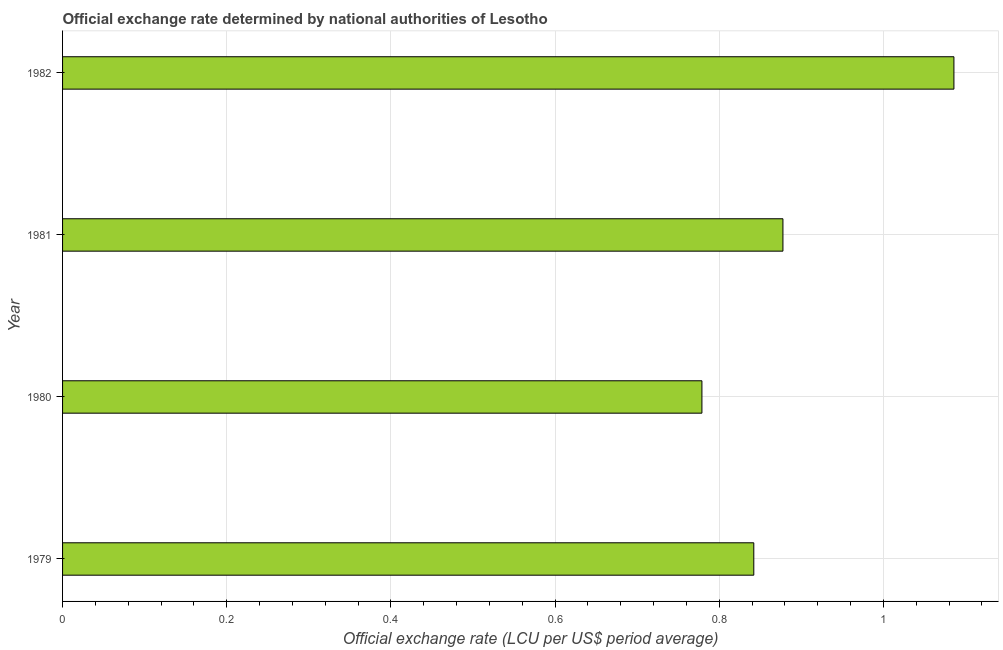What is the title of the graph?
Offer a terse response. Official exchange rate determined by national authorities of Lesotho. What is the label or title of the X-axis?
Offer a terse response. Official exchange rate (LCU per US$ period average). What is the label or title of the Y-axis?
Give a very brief answer. Year. What is the official exchange rate in 1980?
Offer a very short reply. 0.78. Across all years, what is the maximum official exchange rate?
Give a very brief answer. 1.09. Across all years, what is the minimum official exchange rate?
Offer a terse response. 0.78. In which year was the official exchange rate maximum?
Make the answer very short. 1982. What is the sum of the official exchange rate?
Provide a succinct answer. 3.58. What is the difference between the official exchange rate in 1979 and 1981?
Make the answer very short. -0.04. What is the average official exchange rate per year?
Provide a succinct answer. 0.9. What is the median official exchange rate?
Make the answer very short. 0.86. In how many years, is the official exchange rate greater than 1.04 ?
Offer a very short reply. 1. Do a majority of the years between 1982 and 1980 (inclusive) have official exchange rate greater than 0.28 ?
Provide a succinct answer. Yes. What is the ratio of the official exchange rate in 1981 to that in 1982?
Ensure brevity in your answer.  0.81. Is the official exchange rate in 1979 less than that in 1981?
Offer a very short reply. Yes. What is the difference between the highest and the second highest official exchange rate?
Your answer should be compact. 0.21. What is the difference between the highest and the lowest official exchange rate?
Offer a very short reply. 0.31. Are all the bars in the graph horizontal?
Provide a succinct answer. Yes. What is the difference between two consecutive major ticks on the X-axis?
Offer a very short reply. 0.2. Are the values on the major ticks of X-axis written in scientific E-notation?
Offer a terse response. No. What is the Official exchange rate (LCU per US$ period average) of 1979?
Your answer should be compact. 0.84. What is the Official exchange rate (LCU per US$ period average) in 1980?
Give a very brief answer. 0.78. What is the Official exchange rate (LCU per US$ period average) of 1981?
Give a very brief answer. 0.88. What is the Official exchange rate (LCU per US$ period average) of 1982?
Provide a short and direct response. 1.09. What is the difference between the Official exchange rate (LCU per US$ period average) in 1979 and 1980?
Make the answer very short. 0.06. What is the difference between the Official exchange rate (LCU per US$ period average) in 1979 and 1981?
Keep it short and to the point. -0.04. What is the difference between the Official exchange rate (LCU per US$ period average) in 1979 and 1982?
Keep it short and to the point. -0.24. What is the difference between the Official exchange rate (LCU per US$ period average) in 1980 and 1981?
Provide a short and direct response. -0.1. What is the difference between the Official exchange rate (LCU per US$ period average) in 1980 and 1982?
Give a very brief answer. -0.31. What is the difference between the Official exchange rate (LCU per US$ period average) in 1981 and 1982?
Provide a succinct answer. -0.21. What is the ratio of the Official exchange rate (LCU per US$ period average) in 1979 to that in 1980?
Your answer should be compact. 1.08. What is the ratio of the Official exchange rate (LCU per US$ period average) in 1979 to that in 1981?
Ensure brevity in your answer.  0.96. What is the ratio of the Official exchange rate (LCU per US$ period average) in 1979 to that in 1982?
Make the answer very short. 0.78. What is the ratio of the Official exchange rate (LCU per US$ period average) in 1980 to that in 1981?
Give a very brief answer. 0.89. What is the ratio of the Official exchange rate (LCU per US$ period average) in 1980 to that in 1982?
Provide a short and direct response. 0.72. What is the ratio of the Official exchange rate (LCU per US$ period average) in 1981 to that in 1982?
Provide a succinct answer. 0.81. 